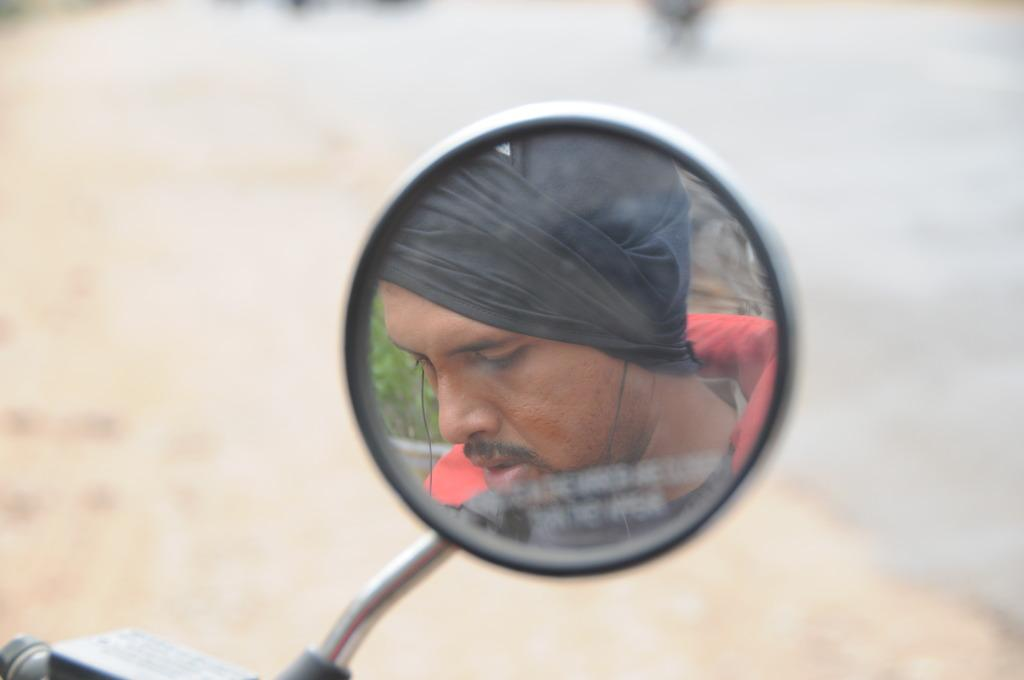What is the main subject of the image? The main subject of the image is a person's face visible in a mirror. How many pizzas are being held by the stick in the image? There is no stick or pizzas present in the image. 